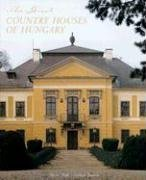Can you tell me more about the architectural style of the house featured on the cover? Certainly, the majestic house depicted on the cover is a fine example of baroque architecture, which is characterized by grandiose elements, bold structures, and a sense of movement and drama in the design. 